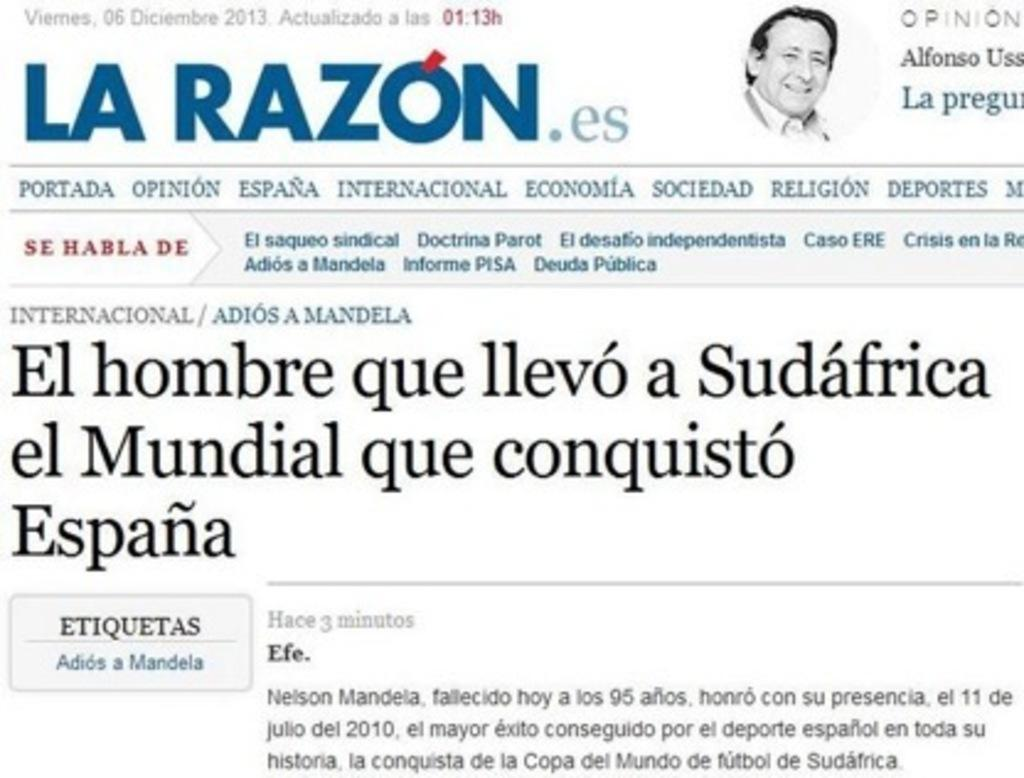What is the main object in the image? There is a paper in the image. What is depicted on the paper? A person's face is depicted on the paper. Are there any words or letters on the paper? Yes, there is text written on the paper. Is there a volcano erupting in the background of the image? No, there is no volcano or any indication of an eruption in the image. What attraction can be seen in the image? There is no specific attraction depicted in the image; it only features a paper with a person's face and text. 